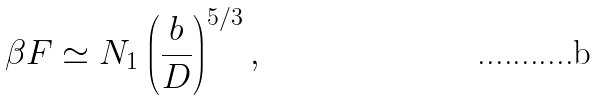<formula> <loc_0><loc_0><loc_500><loc_500>\beta F \simeq N _ { 1 } \left ( \frac { b } { D } \right ) ^ { 5 / 3 } ,</formula> 